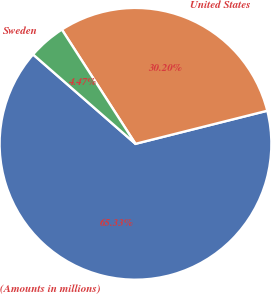Convert chart to OTSL. <chart><loc_0><loc_0><loc_500><loc_500><pie_chart><fcel>(Amounts in millions)<fcel>United States<fcel>Sweden<nl><fcel>65.34%<fcel>30.2%<fcel>4.47%<nl></chart> 